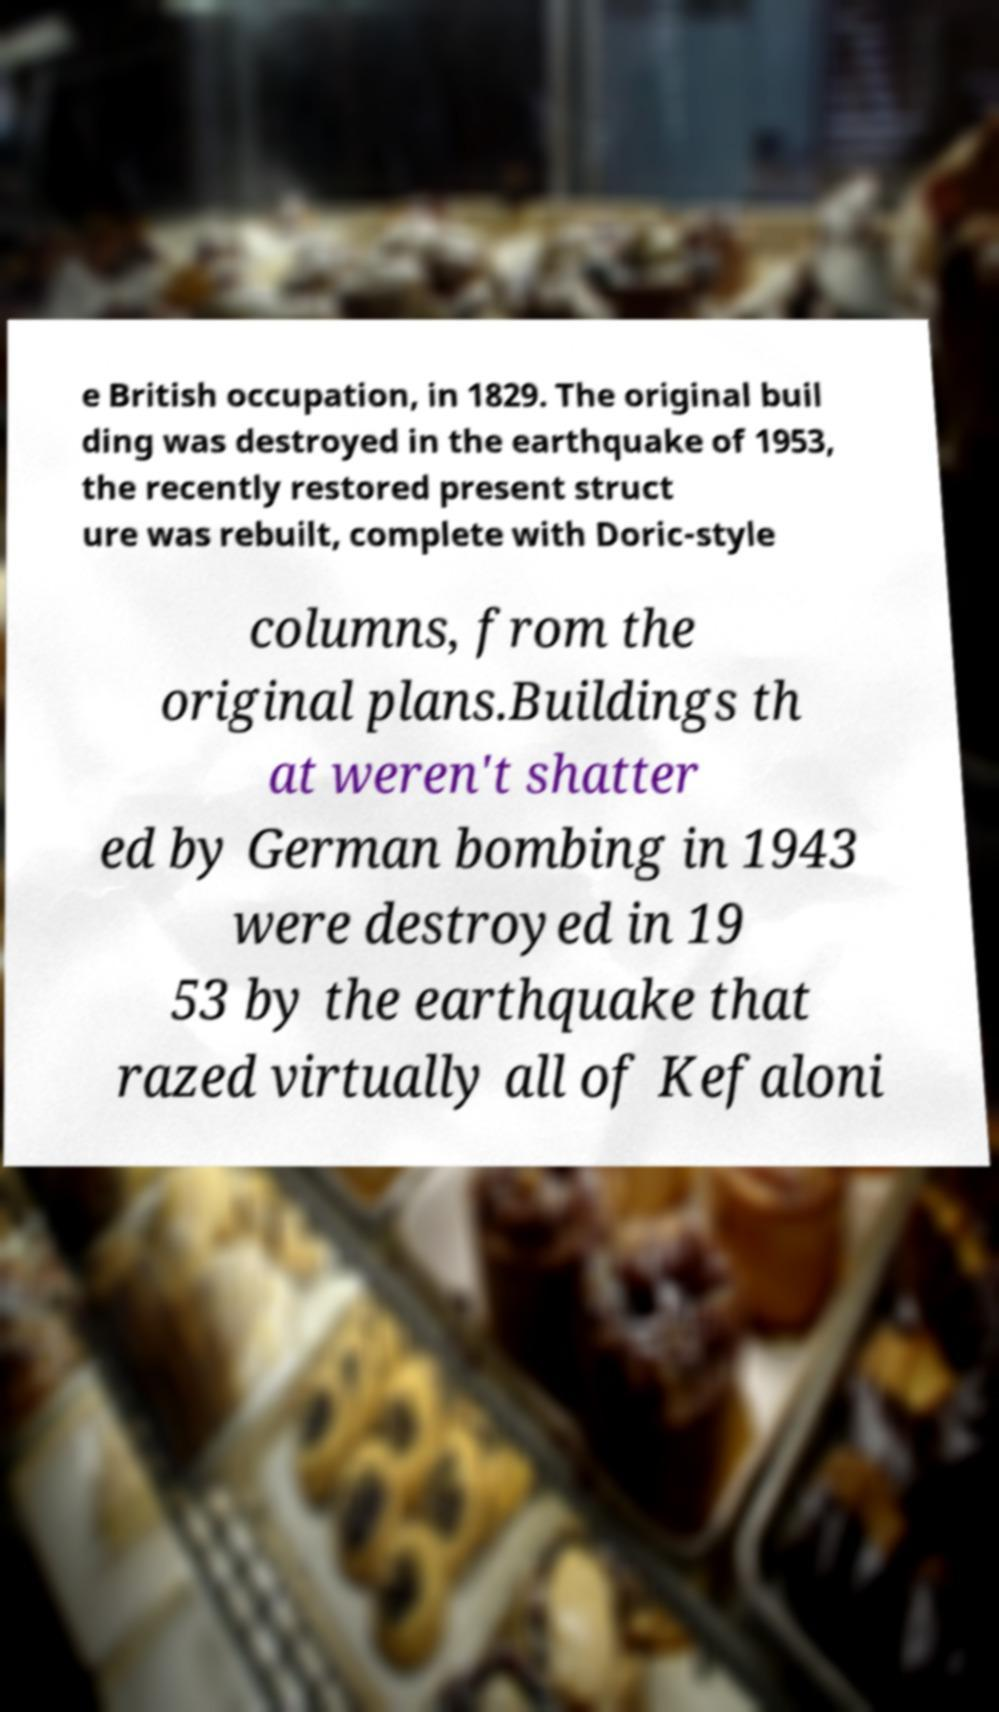I need the written content from this picture converted into text. Can you do that? e British occupation, in 1829. The original buil ding was destroyed in the earthquake of 1953, the recently restored present struct ure was rebuilt, complete with Doric-style columns, from the original plans.Buildings th at weren't shatter ed by German bombing in 1943 were destroyed in 19 53 by the earthquake that razed virtually all of Kefaloni 